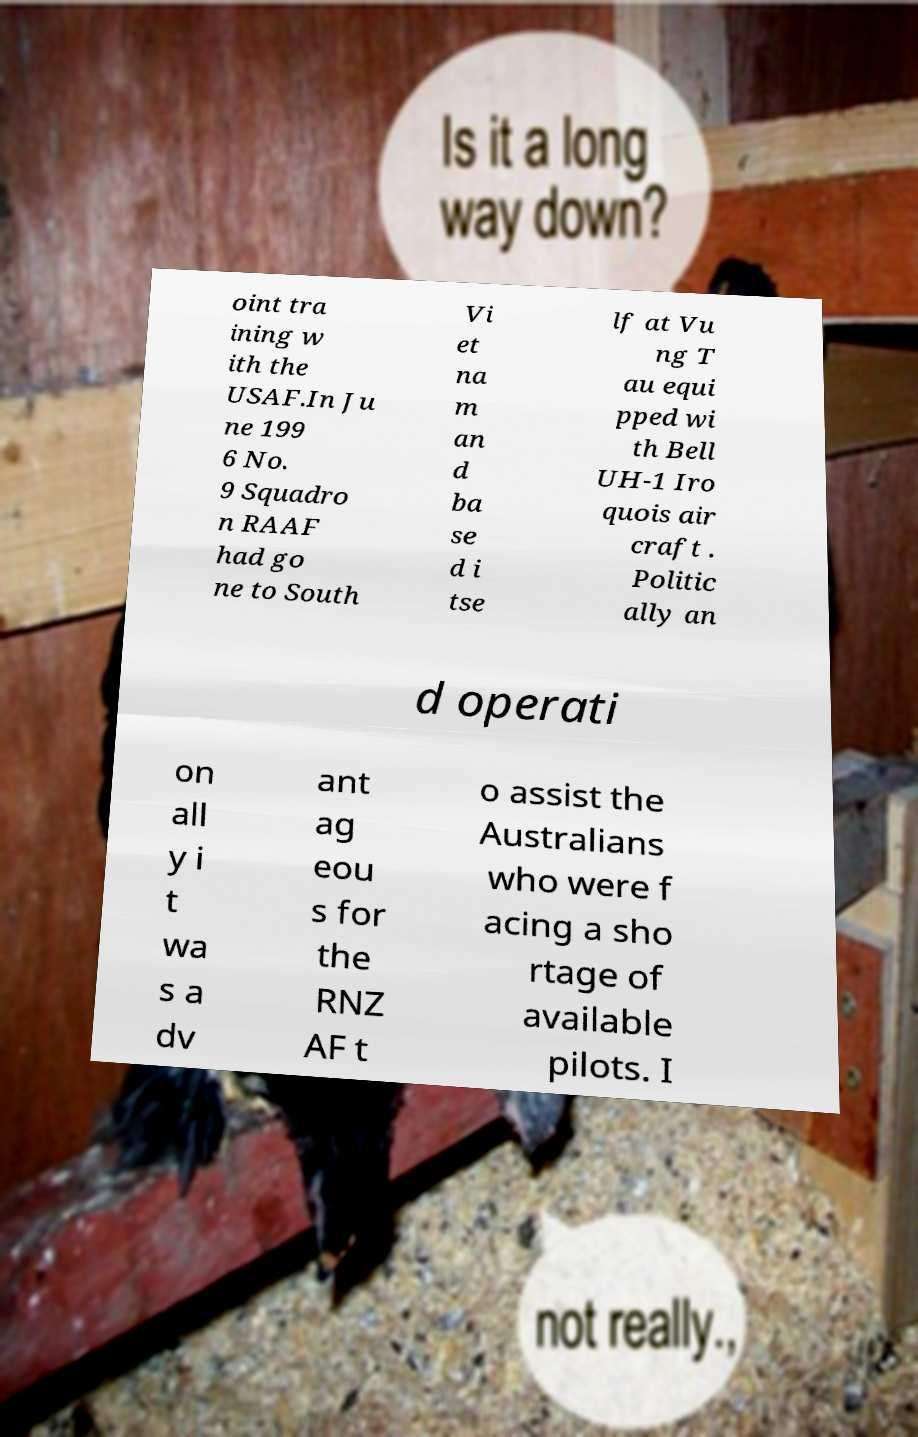Could you extract and type out the text from this image? oint tra ining w ith the USAF.In Ju ne 199 6 No. 9 Squadro n RAAF had go ne to South Vi et na m an d ba se d i tse lf at Vu ng T au equi pped wi th Bell UH-1 Iro quois air craft . Politic ally an d operati on all y i t wa s a dv ant ag eou s for the RNZ AF t o assist the Australians who were f acing a sho rtage of available pilots. I 